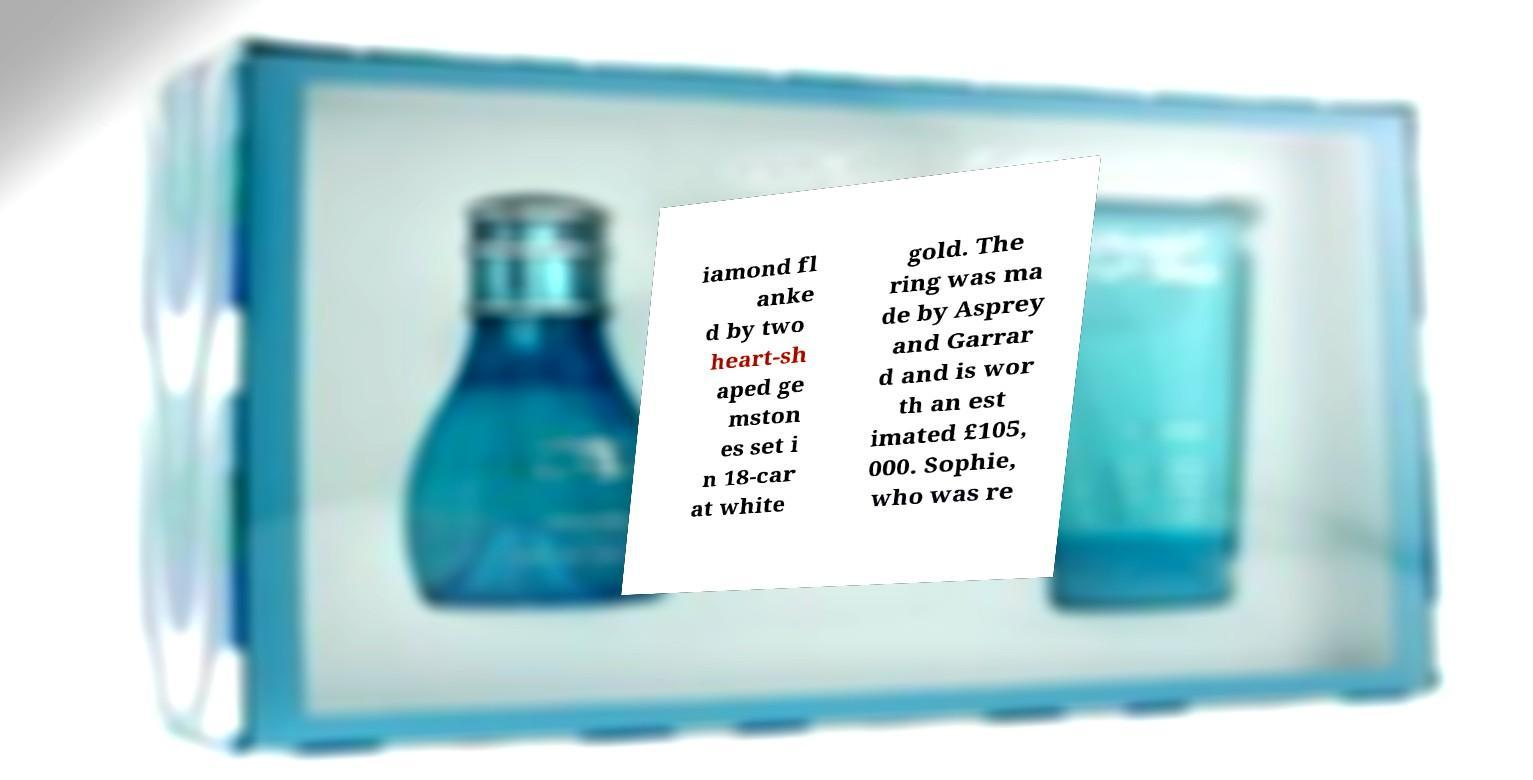I need the written content from this picture converted into text. Can you do that? iamond fl anke d by two heart-sh aped ge mston es set i n 18-car at white gold. The ring was ma de by Asprey and Garrar d and is wor th an est imated £105, 000. Sophie, who was re 